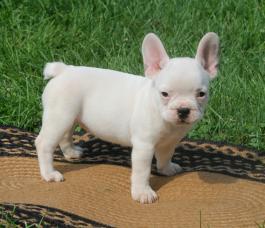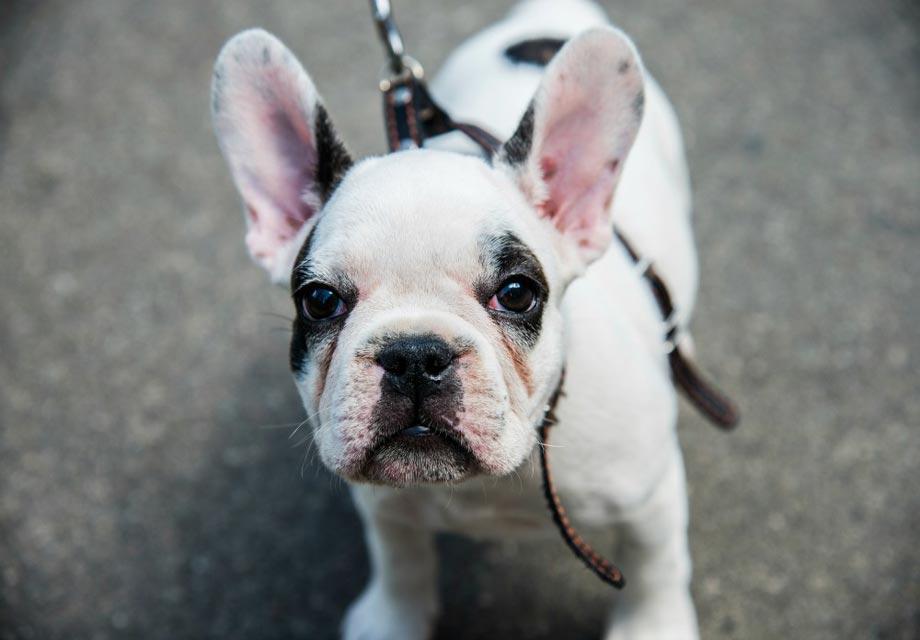The first image is the image on the left, the second image is the image on the right. Assess this claim about the two images: "There are twp puppies in the image pair.". Correct or not? Answer yes or no. Yes. The first image is the image on the left, the second image is the image on the right. Examine the images to the left and right. Is the description "Each image contains a single pug puppy, and each dog's gaze is in the same general direction." accurate? Answer yes or no. Yes. 